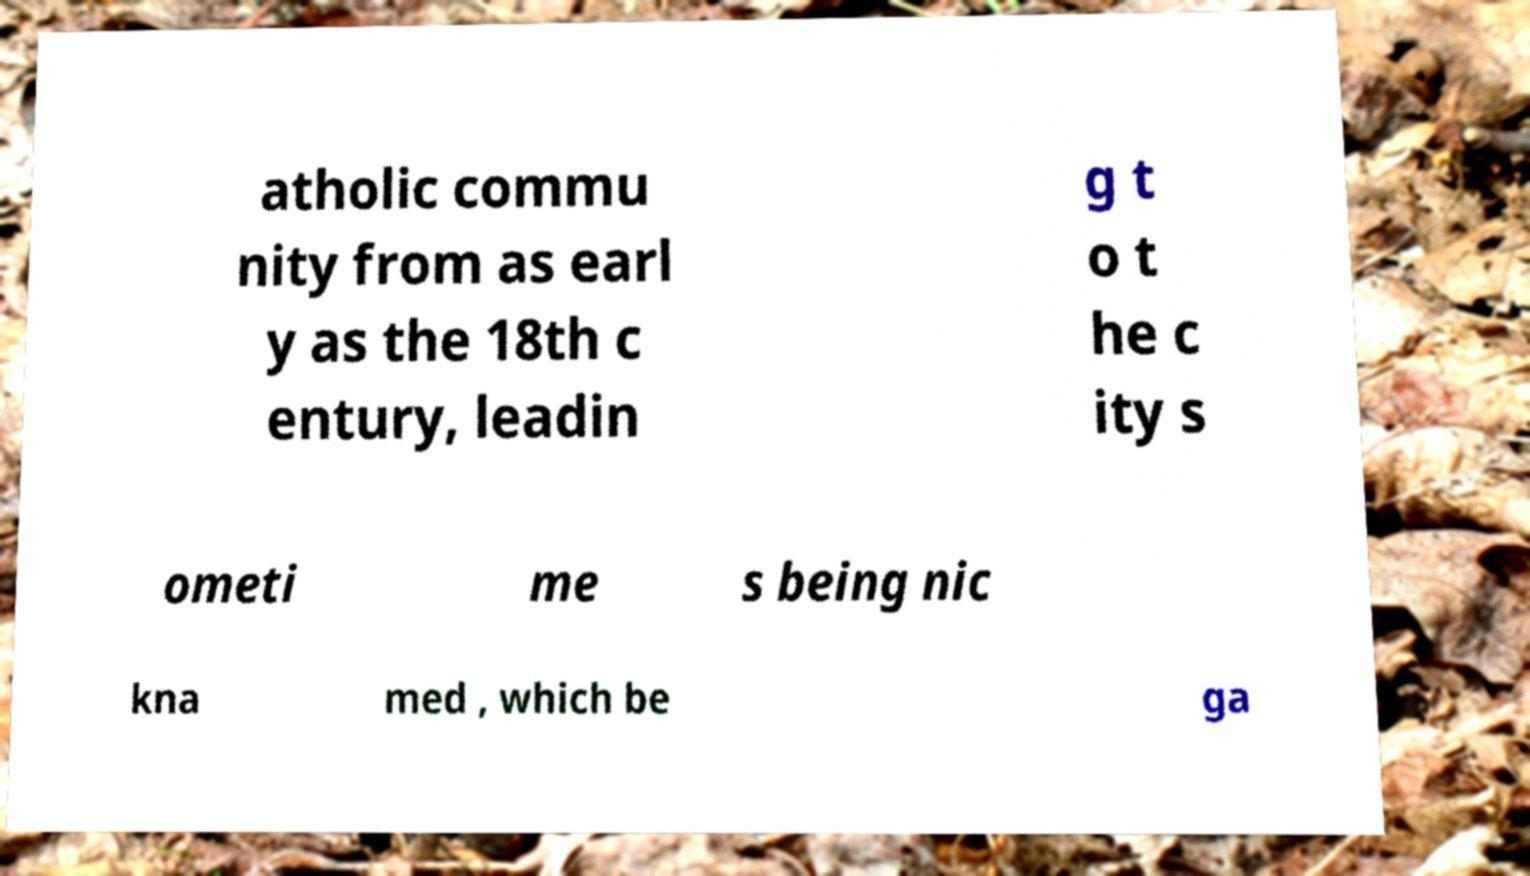Can you accurately transcribe the text from the provided image for me? atholic commu nity from as earl y as the 18th c entury, leadin g t o t he c ity s ometi me s being nic kna med , which be ga 